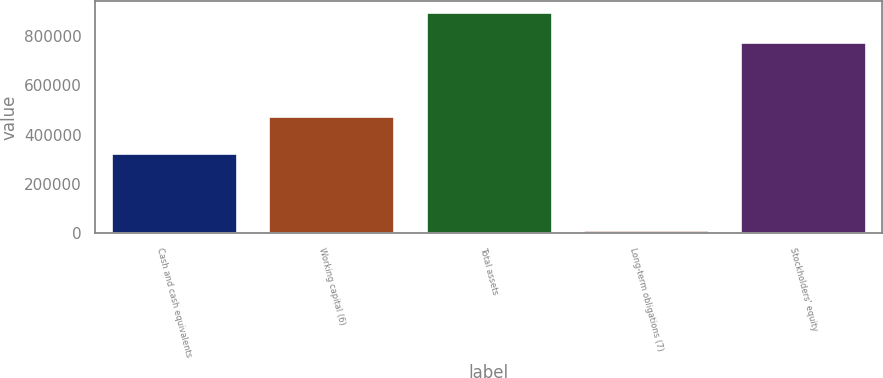Convert chart. <chart><loc_0><loc_0><loc_500><loc_500><bar_chart><fcel>Cash and cash equivalents<fcel>Working capital (6)<fcel>Total assets<fcel>Long-term obligations (7)<fcel>Stockholders' equity<nl><fcel>326695<fcel>475899<fcel>899006<fcel>11515<fcel>776925<nl></chart> 